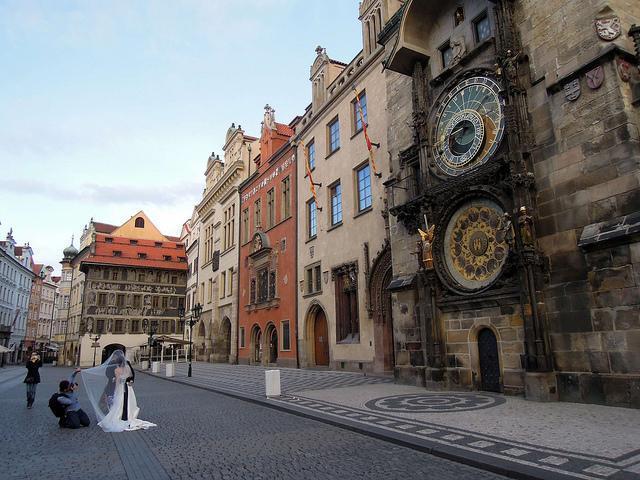How many people are visible?
Give a very brief answer. 3. How many clocks can be seen?
Give a very brief answer. 2. How many suv cars are in the picture?
Give a very brief answer. 0. 